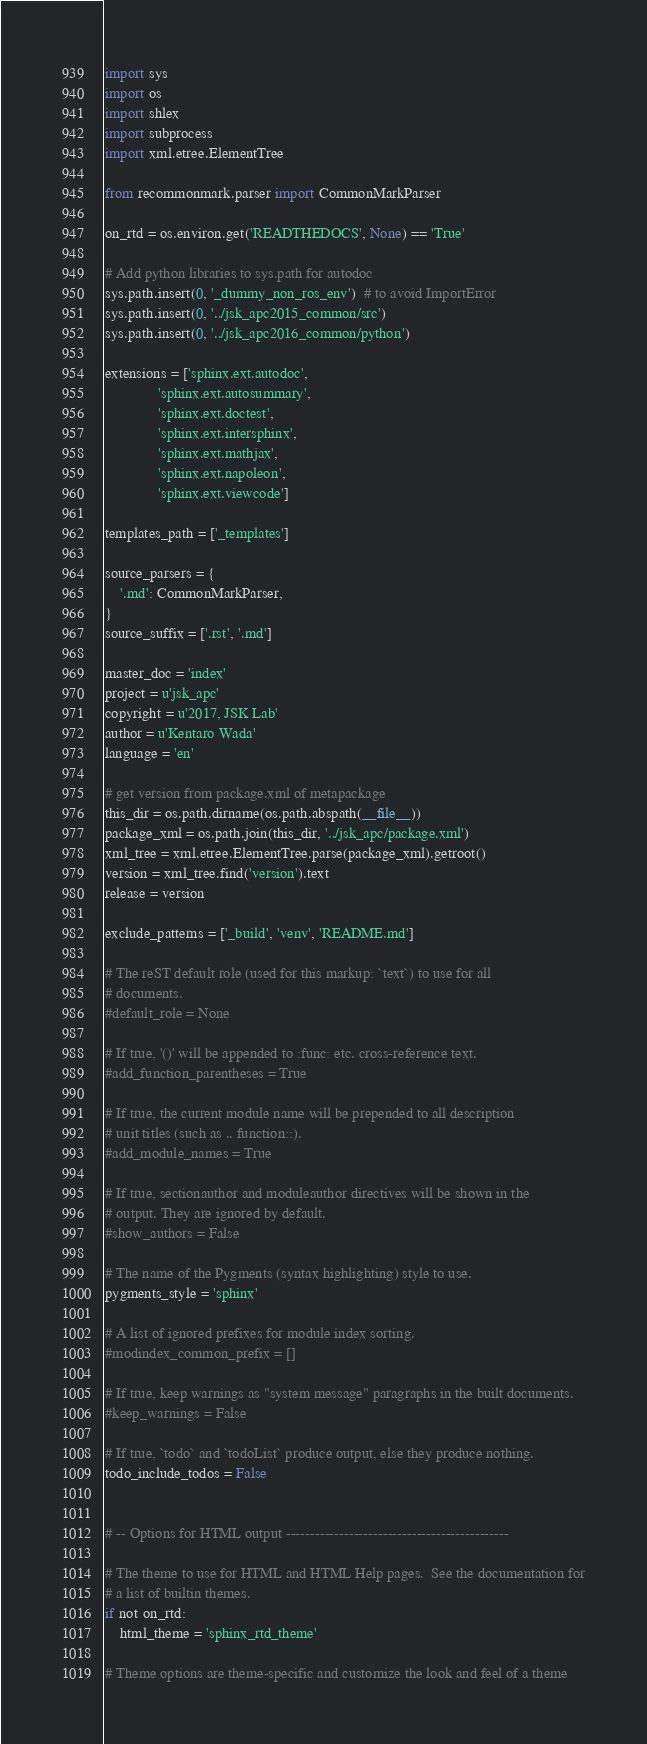<code> <loc_0><loc_0><loc_500><loc_500><_Python_>import sys
import os
import shlex
import subprocess
import xml.etree.ElementTree

from recommonmark.parser import CommonMarkParser

on_rtd = os.environ.get('READTHEDOCS', None) == 'True'

# Add python libraries to sys.path for autodoc
sys.path.insert(0, '_dummy_non_ros_env')  # to avoid ImportError
sys.path.insert(0, '../jsk_apc2015_common/src')
sys.path.insert(0, '../jsk_apc2016_common/python')

extensions = ['sphinx.ext.autodoc',
              'sphinx.ext.autosummary',
              'sphinx.ext.doctest',
              'sphinx.ext.intersphinx',
              'sphinx.ext.mathjax',
              'sphinx.ext.napoleon',
              'sphinx.ext.viewcode']

templates_path = ['_templates']

source_parsers = {
    '.md': CommonMarkParser,
}
source_suffix = ['.rst', '.md']

master_doc = 'index'
project = u'jsk_apc'
copyright = u'2017, JSK Lab'
author = u'Kentaro Wada'
language = 'en'

# get version from package.xml of metapackage
this_dir = os.path.dirname(os.path.abspath(__file__))
package_xml = os.path.join(this_dir, '../jsk_apc/package.xml')
xml_tree = xml.etree.ElementTree.parse(package_xml).getroot()
version = xml_tree.find('version').text
release = version

exclude_patterns = ['_build', 'venv', 'README.md']

# The reST default role (used for this markup: `text`) to use for all
# documents.
#default_role = None

# If true, '()' will be appended to :func: etc. cross-reference text.
#add_function_parentheses = True

# If true, the current module name will be prepended to all description
# unit titles (such as .. function::).
#add_module_names = True

# If true, sectionauthor and moduleauthor directives will be shown in the
# output. They are ignored by default.
#show_authors = False

# The name of the Pygments (syntax highlighting) style to use.
pygments_style = 'sphinx'

# A list of ignored prefixes for module index sorting.
#modindex_common_prefix = []

# If true, keep warnings as "system message" paragraphs in the built documents.
#keep_warnings = False

# If true, `todo` and `todoList` produce output, else they produce nothing.
todo_include_todos = False


# -- Options for HTML output ----------------------------------------------

# The theme to use for HTML and HTML Help pages.  See the documentation for
# a list of builtin themes.
if not on_rtd:
    html_theme = 'sphinx_rtd_theme'

# Theme options are theme-specific and customize the look and feel of a theme</code> 